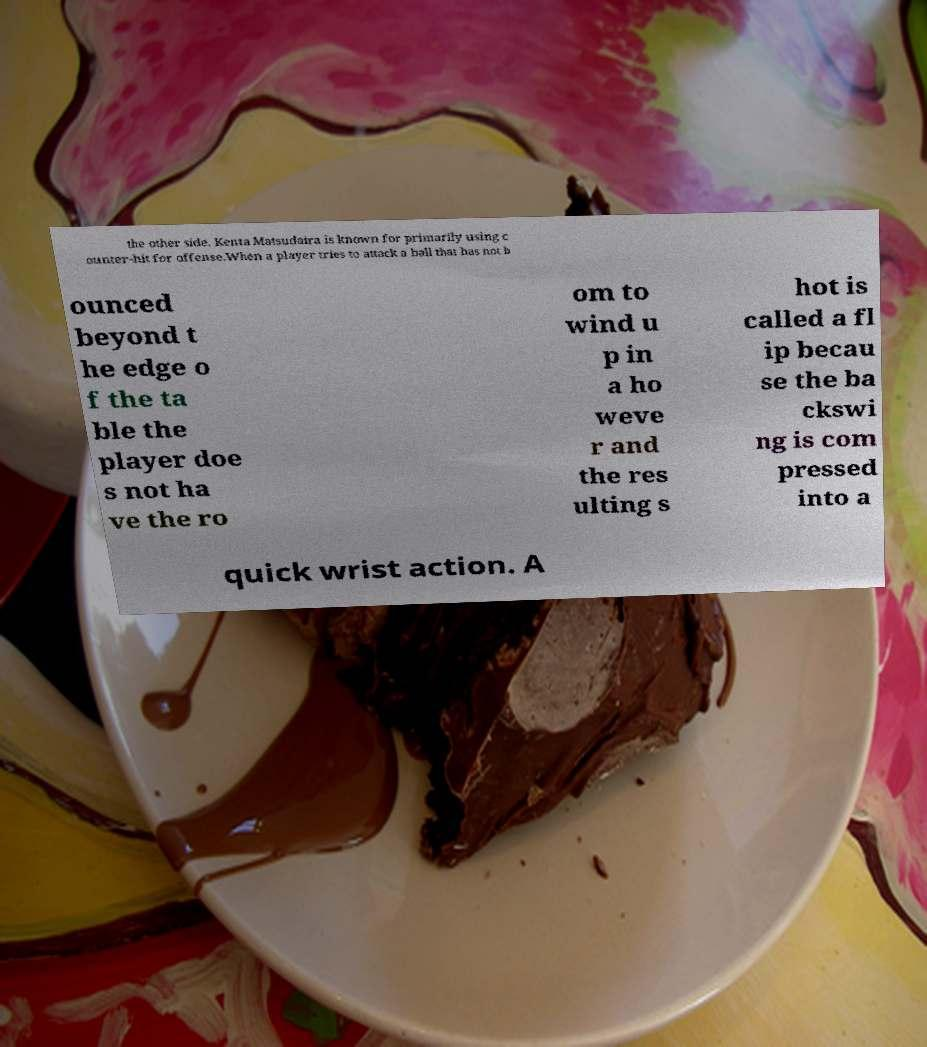For documentation purposes, I need the text within this image transcribed. Could you provide that? the other side. Kenta Matsudaira is known for primarily using c ounter-hit for offense.When a player tries to attack a ball that has not b ounced beyond t he edge o f the ta ble the player doe s not ha ve the ro om to wind u p in a ho weve r and the res ulting s hot is called a fl ip becau se the ba ckswi ng is com pressed into a quick wrist action. A 